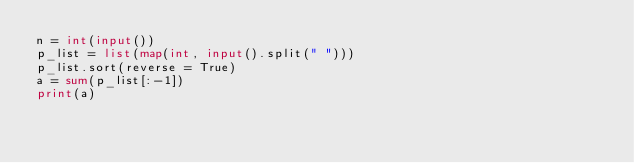Convert code to text. <code><loc_0><loc_0><loc_500><loc_500><_Python_>n = int(input())
p_list = list(map(int, input().split(" ")))
p_list.sort(reverse = True)
a = sum(p_list[:-1])
print(a)   </code> 